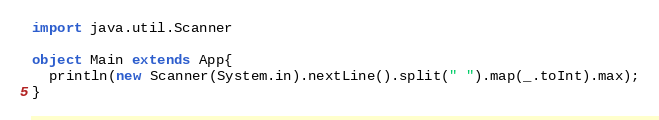<code> <loc_0><loc_0><loc_500><loc_500><_Scala_>import java.util.Scanner

object Main extends App{
  println(new Scanner(System.in).nextLine().split(" ").map(_.toInt).max);
}</code> 